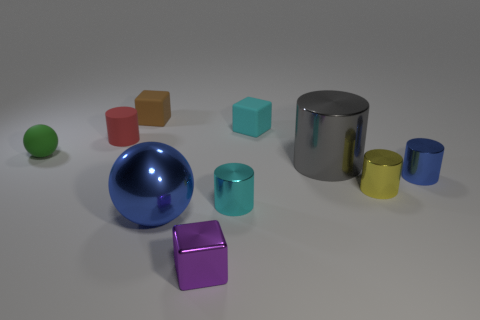How big is the blue metal sphere?
Keep it short and to the point. Large. What is the color of the cube that is the same material as the big blue thing?
Your response must be concise. Purple. How many yellow things are made of the same material as the blue ball?
Offer a very short reply. 1. How many objects are either large red rubber spheres or small matte things to the left of the tiny cyan matte cube?
Offer a terse response. 3. Do the small cube in front of the gray metallic cylinder and the small blue thing have the same material?
Make the answer very short. Yes. What is the color of the metal cube that is the same size as the cyan metal cylinder?
Offer a very short reply. Purple. Is there a yellow thing of the same shape as the tiny red rubber object?
Give a very brief answer. Yes. There is a small rubber cube behind the rubber cube on the right side of the block in front of the gray cylinder; what color is it?
Provide a succinct answer. Brown. What number of metallic objects are either small cyan cylinders or large gray things?
Offer a very short reply. 2. Are there more purple metallic things on the right side of the cyan block than big balls that are in front of the big ball?
Give a very brief answer. No. 